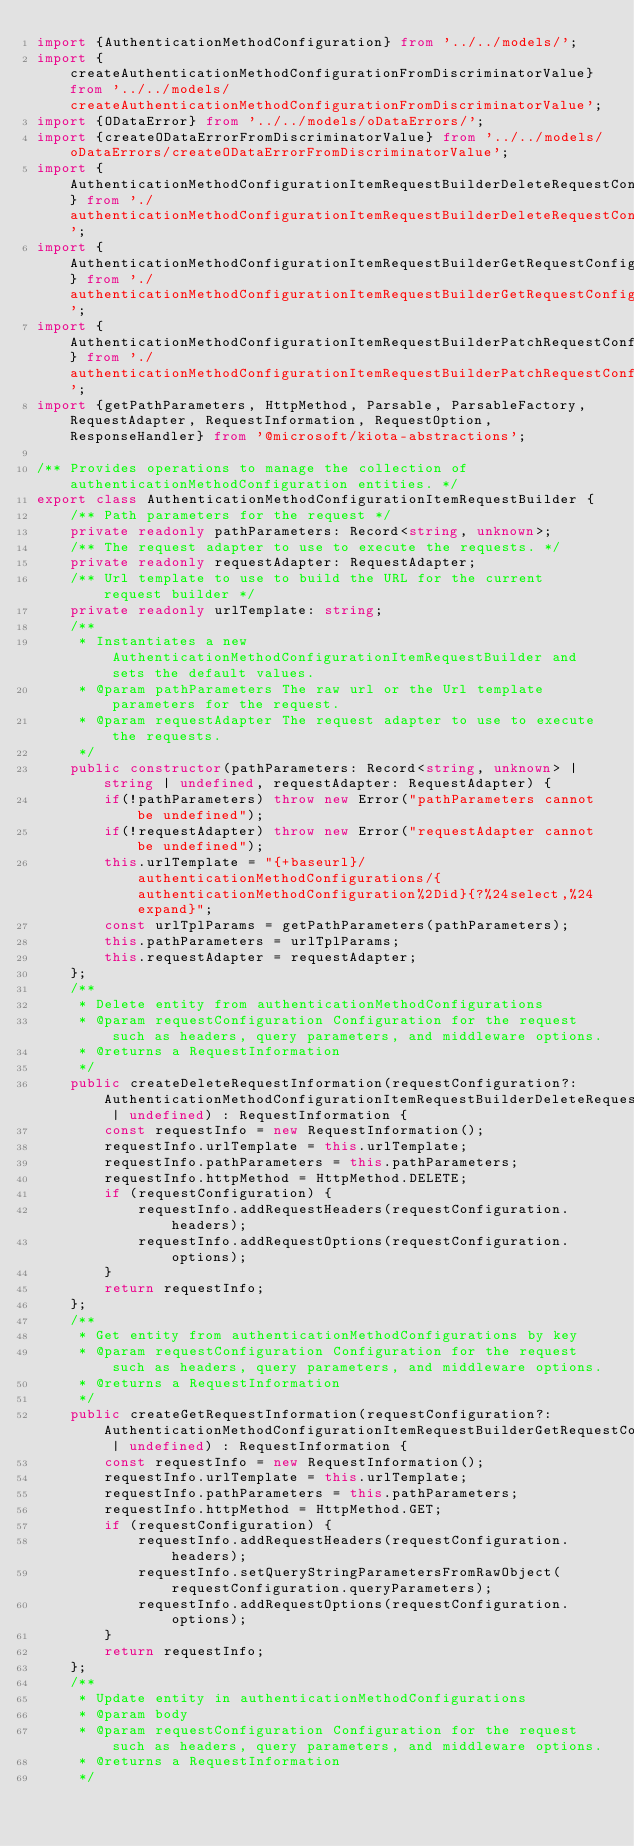<code> <loc_0><loc_0><loc_500><loc_500><_TypeScript_>import {AuthenticationMethodConfiguration} from '../../models/';
import {createAuthenticationMethodConfigurationFromDiscriminatorValue} from '../../models/createAuthenticationMethodConfigurationFromDiscriminatorValue';
import {ODataError} from '../../models/oDataErrors/';
import {createODataErrorFromDiscriminatorValue} from '../../models/oDataErrors/createODataErrorFromDiscriminatorValue';
import {AuthenticationMethodConfigurationItemRequestBuilderDeleteRequestConfiguration} from './authenticationMethodConfigurationItemRequestBuilderDeleteRequestConfiguration';
import {AuthenticationMethodConfigurationItemRequestBuilderGetRequestConfiguration} from './authenticationMethodConfigurationItemRequestBuilderGetRequestConfiguration';
import {AuthenticationMethodConfigurationItemRequestBuilderPatchRequestConfiguration} from './authenticationMethodConfigurationItemRequestBuilderPatchRequestConfiguration';
import {getPathParameters, HttpMethod, Parsable, ParsableFactory, RequestAdapter, RequestInformation, RequestOption, ResponseHandler} from '@microsoft/kiota-abstractions';

/** Provides operations to manage the collection of authenticationMethodConfiguration entities. */
export class AuthenticationMethodConfigurationItemRequestBuilder {
    /** Path parameters for the request */
    private readonly pathParameters: Record<string, unknown>;
    /** The request adapter to use to execute the requests. */
    private readonly requestAdapter: RequestAdapter;
    /** Url template to use to build the URL for the current request builder */
    private readonly urlTemplate: string;
    /**
     * Instantiates a new AuthenticationMethodConfigurationItemRequestBuilder and sets the default values.
     * @param pathParameters The raw url or the Url template parameters for the request.
     * @param requestAdapter The request adapter to use to execute the requests.
     */
    public constructor(pathParameters: Record<string, unknown> | string | undefined, requestAdapter: RequestAdapter) {
        if(!pathParameters) throw new Error("pathParameters cannot be undefined");
        if(!requestAdapter) throw new Error("requestAdapter cannot be undefined");
        this.urlTemplate = "{+baseurl}/authenticationMethodConfigurations/{authenticationMethodConfiguration%2Did}{?%24select,%24expand}";
        const urlTplParams = getPathParameters(pathParameters);
        this.pathParameters = urlTplParams;
        this.requestAdapter = requestAdapter;
    };
    /**
     * Delete entity from authenticationMethodConfigurations
     * @param requestConfiguration Configuration for the request such as headers, query parameters, and middleware options.
     * @returns a RequestInformation
     */
    public createDeleteRequestInformation(requestConfiguration?: AuthenticationMethodConfigurationItemRequestBuilderDeleteRequestConfiguration | undefined) : RequestInformation {
        const requestInfo = new RequestInformation();
        requestInfo.urlTemplate = this.urlTemplate;
        requestInfo.pathParameters = this.pathParameters;
        requestInfo.httpMethod = HttpMethod.DELETE;
        if (requestConfiguration) {
            requestInfo.addRequestHeaders(requestConfiguration.headers);
            requestInfo.addRequestOptions(requestConfiguration.options);
        }
        return requestInfo;
    };
    /**
     * Get entity from authenticationMethodConfigurations by key
     * @param requestConfiguration Configuration for the request such as headers, query parameters, and middleware options.
     * @returns a RequestInformation
     */
    public createGetRequestInformation(requestConfiguration?: AuthenticationMethodConfigurationItemRequestBuilderGetRequestConfiguration | undefined) : RequestInformation {
        const requestInfo = new RequestInformation();
        requestInfo.urlTemplate = this.urlTemplate;
        requestInfo.pathParameters = this.pathParameters;
        requestInfo.httpMethod = HttpMethod.GET;
        if (requestConfiguration) {
            requestInfo.addRequestHeaders(requestConfiguration.headers);
            requestInfo.setQueryStringParametersFromRawObject(requestConfiguration.queryParameters);
            requestInfo.addRequestOptions(requestConfiguration.options);
        }
        return requestInfo;
    };
    /**
     * Update entity in authenticationMethodConfigurations
     * @param body 
     * @param requestConfiguration Configuration for the request such as headers, query parameters, and middleware options.
     * @returns a RequestInformation
     */</code> 